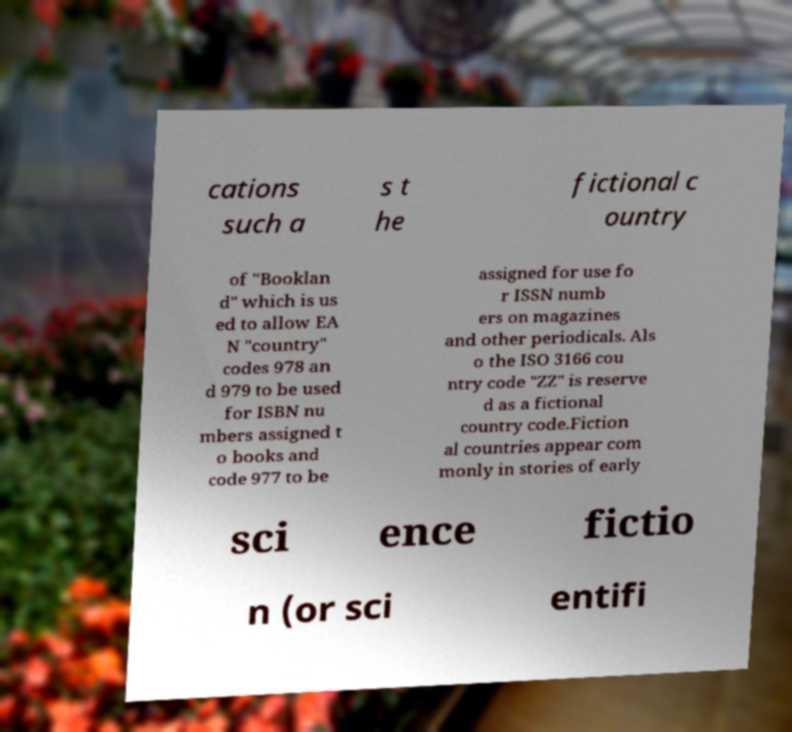Could you assist in decoding the text presented in this image and type it out clearly? cations such a s t he fictional c ountry of "Booklan d" which is us ed to allow EA N "country" codes 978 an d 979 to be used for ISBN nu mbers assigned t o books and code 977 to be assigned for use fo r ISSN numb ers on magazines and other periodicals. Als o the ISO 3166 cou ntry code "ZZ" is reserve d as a fictional country code.Fiction al countries appear com monly in stories of early sci ence fictio n (or sci entifi 